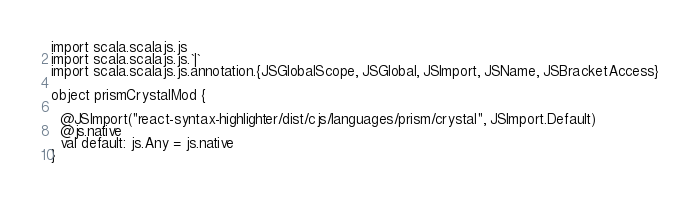Convert code to text. <code><loc_0><loc_0><loc_500><loc_500><_Scala_>import scala.scalajs.js
import scala.scalajs.js.`|`
import scala.scalajs.js.annotation.{JSGlobalScope, JSGlobal, JSImport, JSName, JSBracketAccess}

object prismCrystalMod {
  
  @JSImport("react-syntax-highlighter/dist/cjs/languages/prism/crystal", JSImport.Default)
  @js.native
  val default: js.Any = js.native
}
</code> 